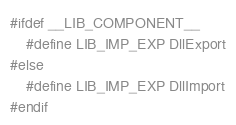Convert code to text. <code><loc_0><loc_0><loc_500><loc_500><_C++_>#ifdef __LIB_COMPONENT__
	#define LIB_IMP_EXP DllExport
#else
	#define LIB_IMP_EXP DllImport
#endif
</code> 